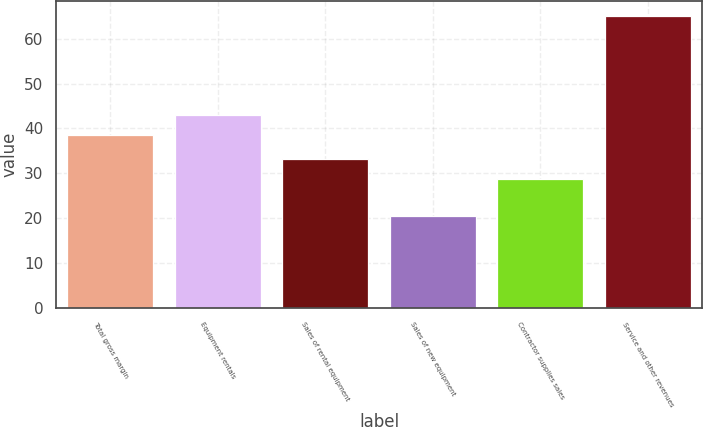Convert chart. <chart><loc_0><loc_0><loc_500><loc_500><bar_chart><fcel>Total gross margin<fcel>Equipment rentals<fcel>Sales of rental equipment<fcel>Sales of new equipment<fcel>Contractor supplies sales<fcel>Service and other revenues<nl><fcel>38.5<fcel>42.97<fcel>33.17<fcel>20.4<fcel>28.7<fcel>65.1<nl></chart> 